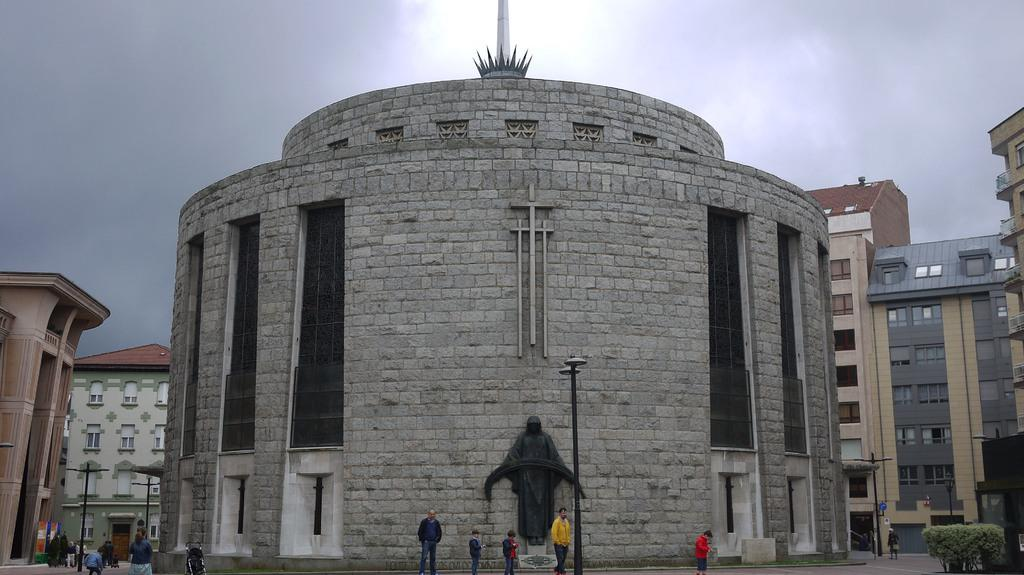How many people are in the image? There are persons in the image, but the exact number is not specified. What else can be seen in the image besides the persons? There are poles and buildings visible in the image. Where is the plant located in the image? The plant is in the bottom right of the image. What is visible at the top of the image? The sky is visible at the top of the image. What type of letters are being exchanged between the persons in the image? There is no indication in the image that the persons are exchanging letters, so it cannot be determined from the picture. 